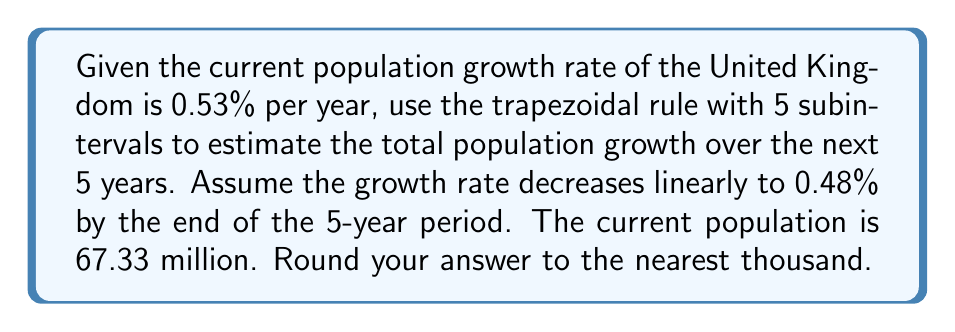Give your solution to this math problem. To solve this problem, we'll use the trapezoidal rule for numerical integration. The steps are as follows:

1) First, let's define our function. The population growth rate is decreasing linearly from 0.53% to 0.48% over 5 years. We can express this as:

   $$r(t) = 0.0053 - 0.0001t$$

   where $t$ is the time in years from 0 to 5.

2) The population growth over the 5 years is given by the integral:

   $$\int_0^5 67.33 \cdot r(t) dt$$

3) We'll use the trapezoidal rule with 5 subintervals. The formula is:

   $$\int_a^b f(x)dx \approx \frac{h}{2}[f(x_0) + 2f(x_1) + 2f(x_2) + 2f(x_3) + 2f(x_4) + f(x_5)]$$

   where $h = (b-a)/n = 5/5 = 1$

4) Let's calculate the function values:
   
   $f(0) = 67.33 \cdot (0.0053 - 0.0001 \cdot 0) = 0.356849$
   $f(1) = 67.33 \cdot (0.0053 - 0.0001 \cdot 1) = 0.350116$
   $f(2) = 67.33 \cdot (0.0053 - 0.0001 \cdot 2) = 0.343383$
   $f(3) = 67.33 \cdot (0.0053 - 0.0001 \cdot 3) = 0.336650$
   $f(4) = 67.33 \cdot (0.0053 - 0.0001 \cdot 4) = 0.329917$
   $f(5) = 67.33 \cdot (0.0053 - 0.0001 \cdot 5) = 0.323184$

5) Applying the trapezoidal rule:

   $$\frac{1}{2}[0.356849 + 2(0.350116 + 0.343383 + 0.336650 + 0.329917) + 0.323184]$$
   
   $$= \frac{1}{2}[0.356849 + 2(1.360066) + 0.323184]$$
   
   $$= \frac{1}{2}[3.400165] = 1.7000825$$

6) This result represents the population growth in millions over the 5-year period.

7) Rounding to the nearest thousand: 1,700,000
Answer: 1,700,000 